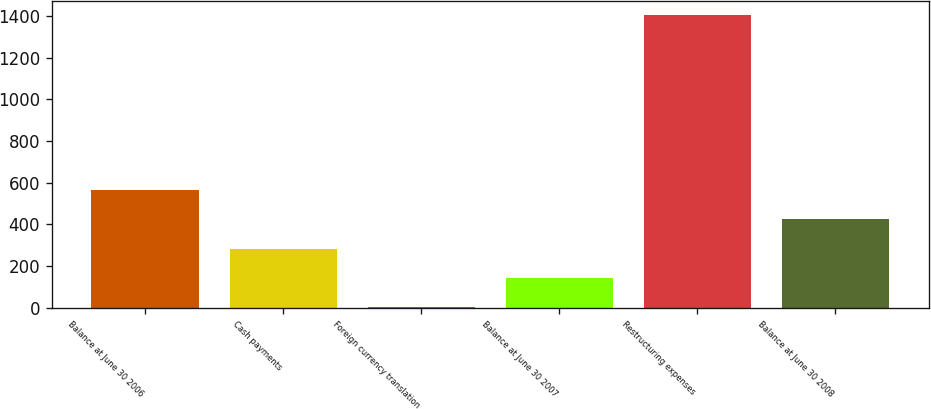<chart> <loc_0><loc_0><loc_500><loc_500><bar_chart><fcel>Balance at June 30 2006<fcel>Cash payments<fcel>Foreign currency translation<fcel>Balance at June 30 2007<fcel>Restructuring expenses<fcel>Balance at June 30 2008<nl><fcel>562.6<fcel>282.8<fcel>3<fcel>142.9<fcel>1402<fcel>422.7<nl></chart> 